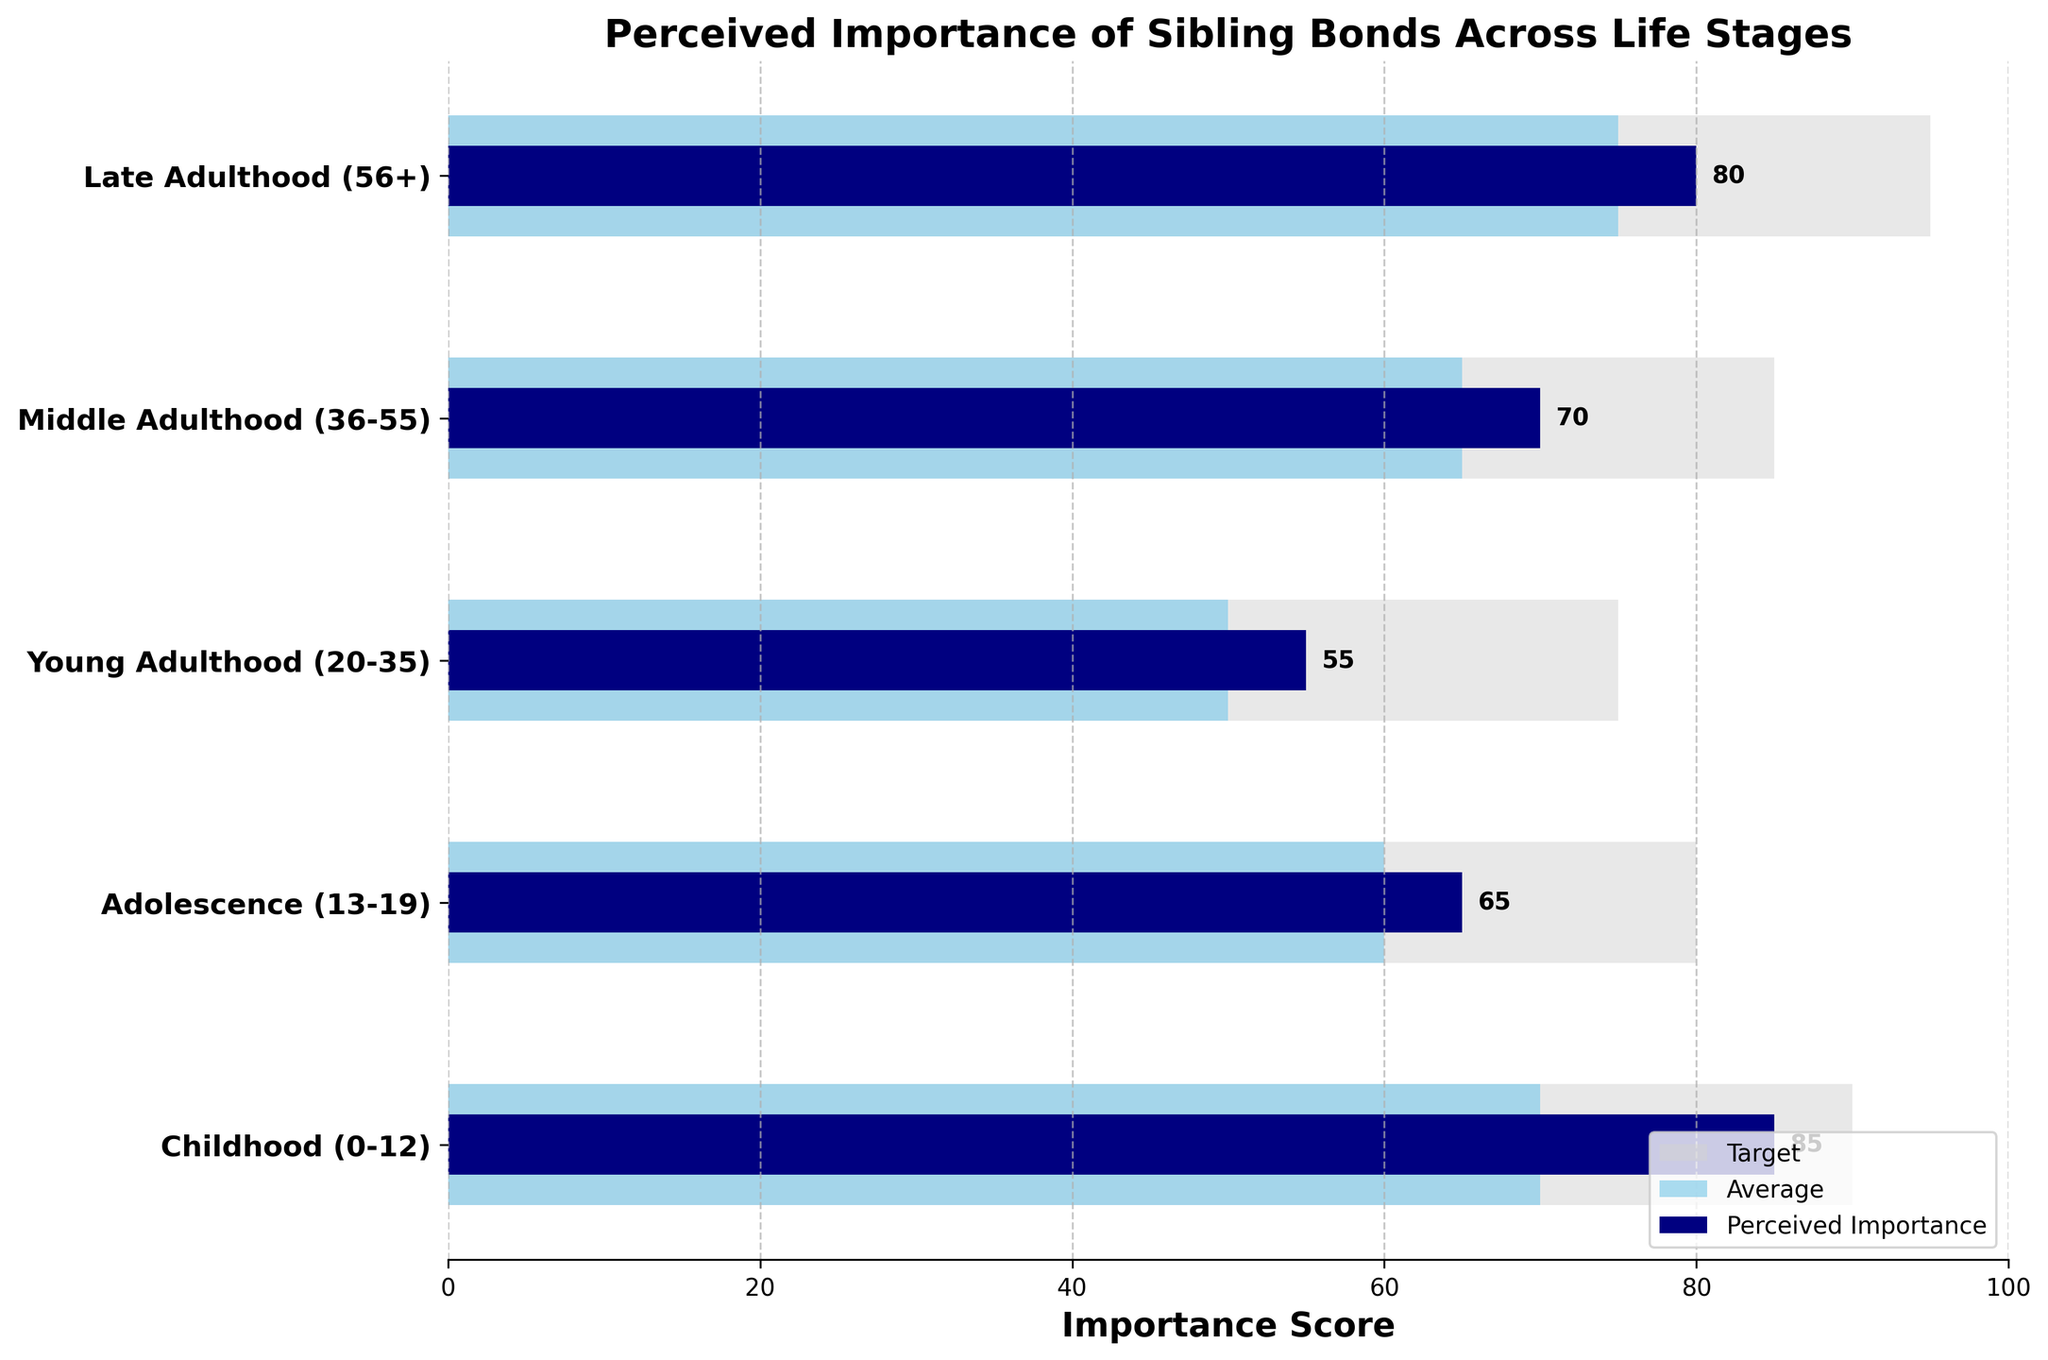What is the title of the figure? The title of the figure is written prominently at the top. It summarizes what the chart is about.
Answer: Perceived Importance of Sibling Bonds Across Life Stages What life stage has the highest perceived importance of sibling bonds? We look at the bars representing 'Perceived Importance' and identify the one with the longest length.
Answer: Childhood (0-12) How does the perceived importance in Late Adulthood compare to that in Young Adulthood? We compare the length of the 'Perceived Importance' bars for Late Adulthood and Young Adulthood.
Answer: Higher in Late Adulthood What is the average importance score for Middle Adulthood? We look at the length of the 'Average' bar corresponding to Middle Adulthood.
Answer: 65 Which life stage falls short of its target by the largest margin? We calculate the difference between 'Target' and 'Perceived Importance' for each life stage and find the maximum. For Childhood: 90 - 85 = 5. For Adolescence: 80 - 65 = 15. For Young Adulthood: 75 - 55 = 20. For Middle Adulthood: 85 - 70 = 15. For Late Adulthood: 95 - 80 = 15.
Answer: Young Adulthood (20-35) Does any life stage meet or exceed its target for perceived importance of sibling bonds? Check if the 'Perceived Importance' bar reaches or surpasses the 'Target' bar for any life stage.
Answer: No What is the color used to represent 'Average' importance scores? We look at the legend and match the 'Average' label with its bar color.
Answer: Skyblue How much higher is the perceived importance of sibling bonds in Childhood compared to Young Adulthood? Find the 'Perceived Importance' values for both stages and subtract the smaller from the larger. Childhood: 85, Young Adulthood: 55. Difference: 85 - 55.
Answer: 30 What is the target importance score for Late Adulthood? We look at the length of the 'Target' bar corresponding to Late Adulthood.
Answer: 95 